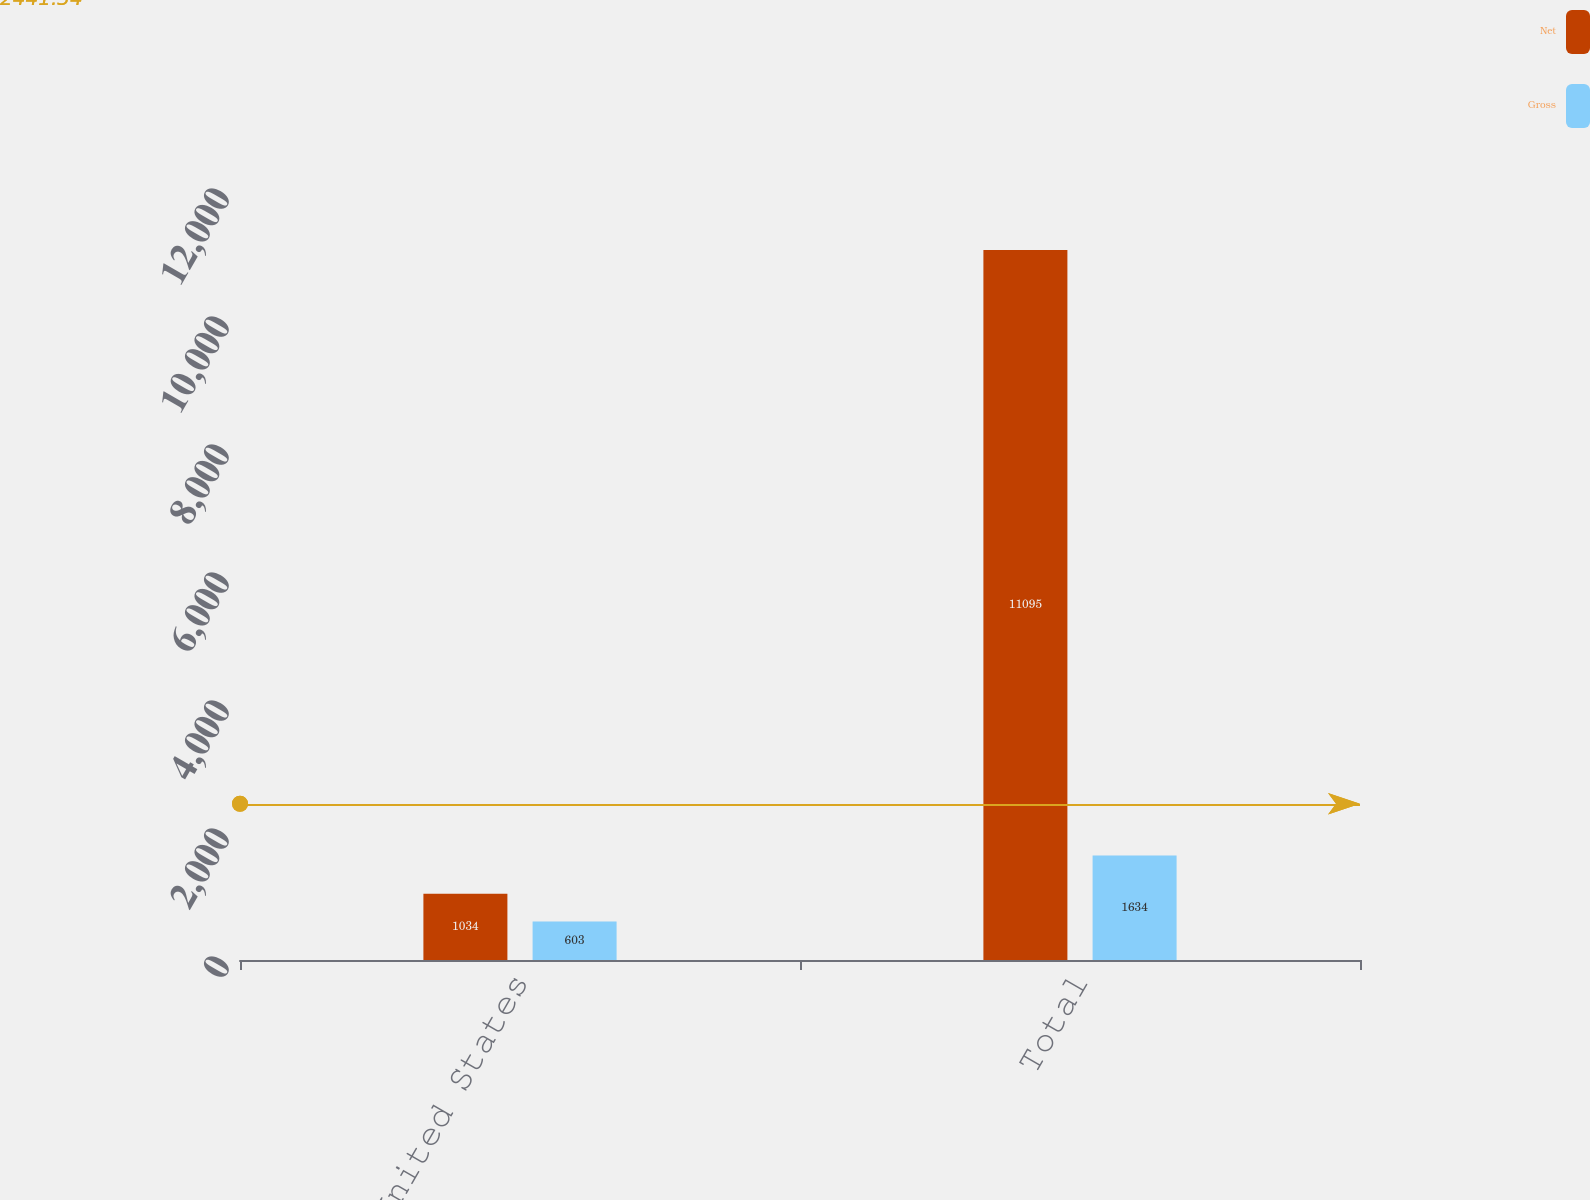Convert chart to OTSL. <chart><loc_0><loc_0><loc_500><loc_500><stacked_bar_chart><ecel><fcel>United States<fcel>Total<nl><fcel>Net<fcel>1034<fcel>11095<nl><fcel>Gross<fcel>603<fcel>1634<nl></chart> 